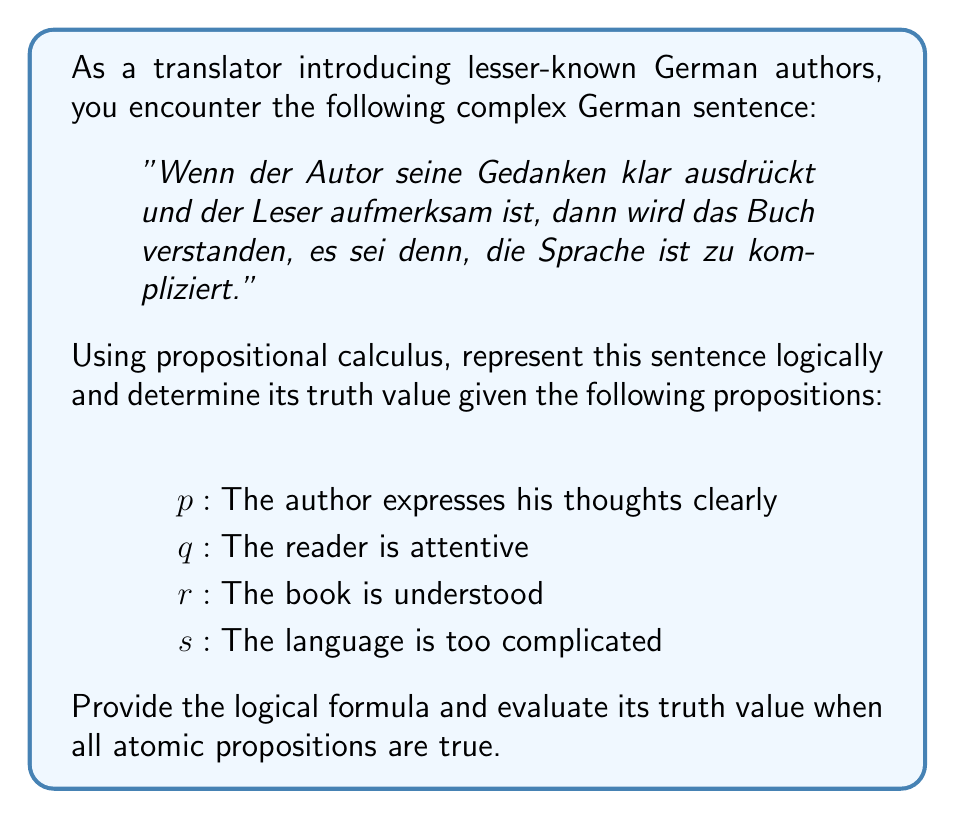Provide a solution to this math problem. Let's break down the sentence and represent it using propositional calculus:

1. The main structure of the sentence is an implication: "If... then..., unless..."

2. The antecedent (if part) is a conjunction: "The author expresses his thoughts clearly AND the reader is attentive"

3. The consequent (then part) is: "The book is understood"

4. The "unless" part introduces an exception: "The language is too complicated"

We can represent this logically as:

$$(p \land q) \rightarrow (r \lor \neg s)$$

This formula reads: "If the author expresses his thoughts clearly (p) and the reader is attentive (q), then the book is understood (r) or it's not the case that the language is too complicated (¬s)."

To evaluate the truth value when all atomic propositions are true:

1. $p$ is true
2. $q$ is true
3. $r$ is true
4. $s$ is true

Let's evaluate step by step:

1. $(p \land q)$ is true (both $p$ and $q$ are true)
2. $(r \lor \neg s)$ is true (because $r$ is true, regardless of $s$)
3. The implication $(p \land q) \rightarrow (r \lor \neg s)$ is true because when the antecedent is true and the consequent is true, the implication is true.

Therefore, the entire proposition is true when all atomic propositions are true.
Answer: The logical formula is $$(p \land q) \rightarrow (r \lor \neg s)$$
The truth value is true when all atomic propositions are true. 